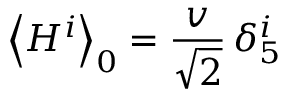Convert formula to latex. <formula><loc_0><loc_0><loc_500><loc_500>\left \langle H ^ { i } \right \rangle _ { 0 } = \frac { v } { \sqrt { 2 } } \, \delta _ { 5 } ^ { i }</formula> 